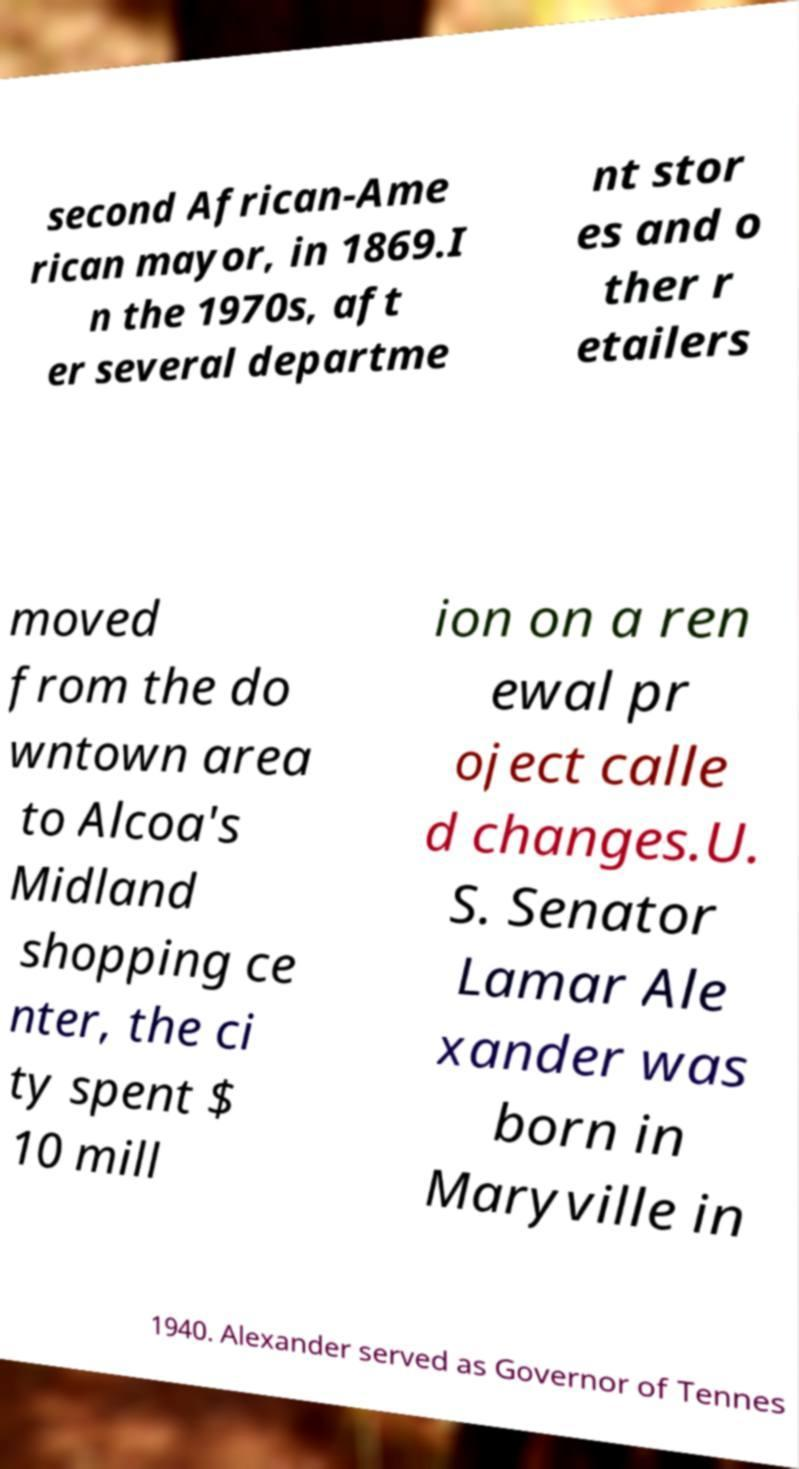Can you accurately transcribe the text from the provided image for me? second African-Ame rican mayor, in 1869.I n the 1970s, aft er several departme nt stor es and o ther r etailers moved from the do wntown area to Alcoa's Midland shopping ce nter, the ci ty spent $ 10 mill ion on a ren ewal pr oject calle d changes.U. S. Senator Lamar Ale xander was born in Maryville in 1940. Alexander served as Governor of Tennes 